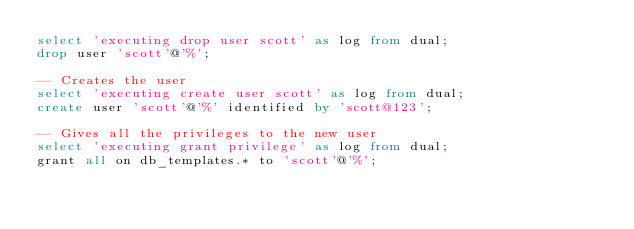<code> <loc_0><loc_0><loc_500><loc_500><_SQL_>select 'executing drop user scott' as log from dual;
drop user 'scott'@'%';

-- Creates the user
select 'executing create user scott' as log from dual;
create user 'scott'@'%' identified by 'scott@123';

-- Gives all the privileges to the new user
select 'executing grant privilege' as log from dual;
grant all on db_templates.* to 'scott'@'%';</code> 